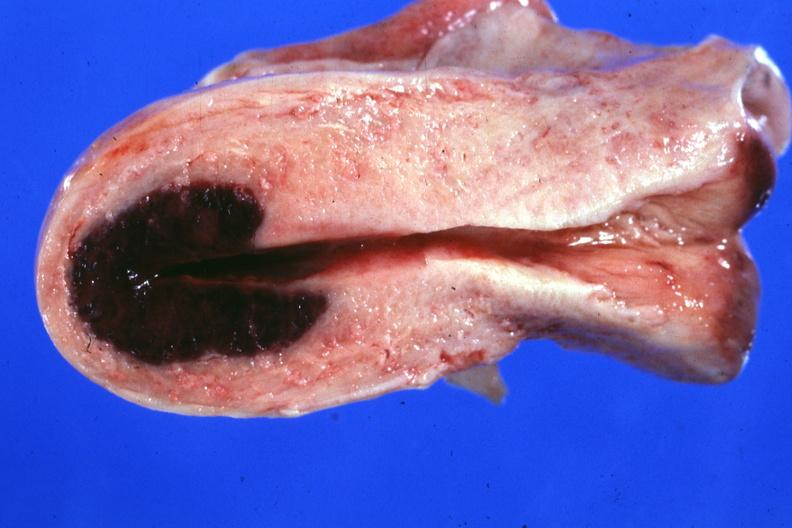what said to have adenosis adenomyosis hemorrhage probably due to shock?
Answer the question using a single word or phrase. Lesion in dome of uterus 